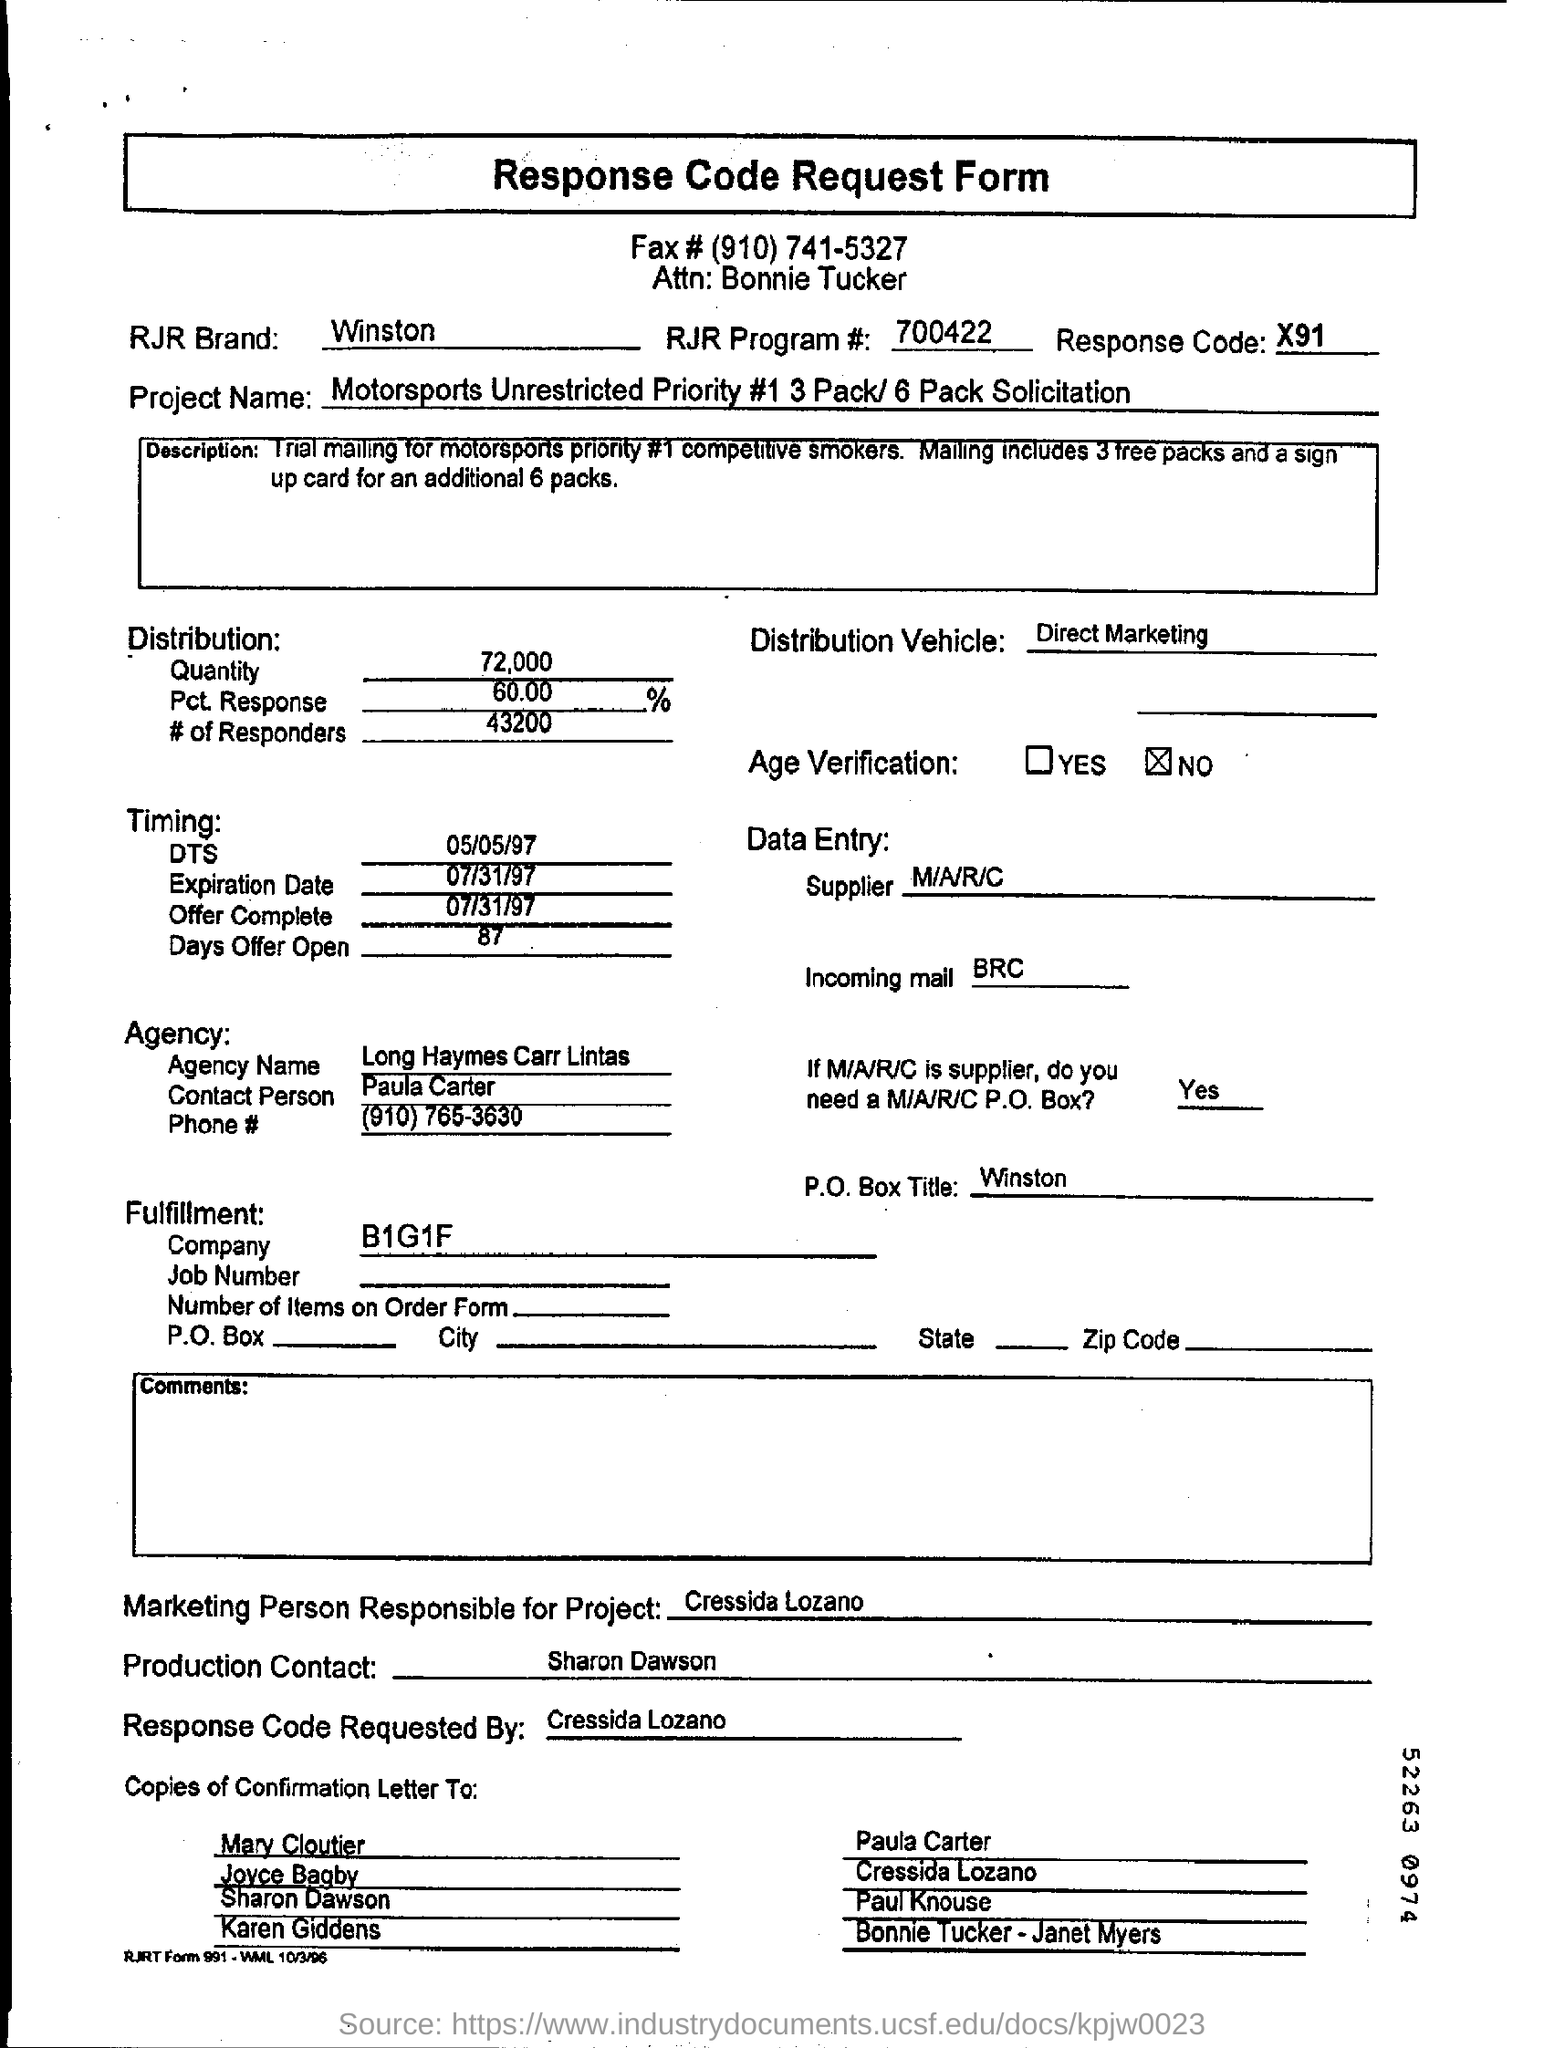Can you tell me the purpose of the Response Code? The Response Code, which is X91 in this case, is likely used to track responses from the recipients of this direct marketing campaign. It allows the company to monitor the effectiveness of the campaign and who is responding for further analysis and follow-up. 